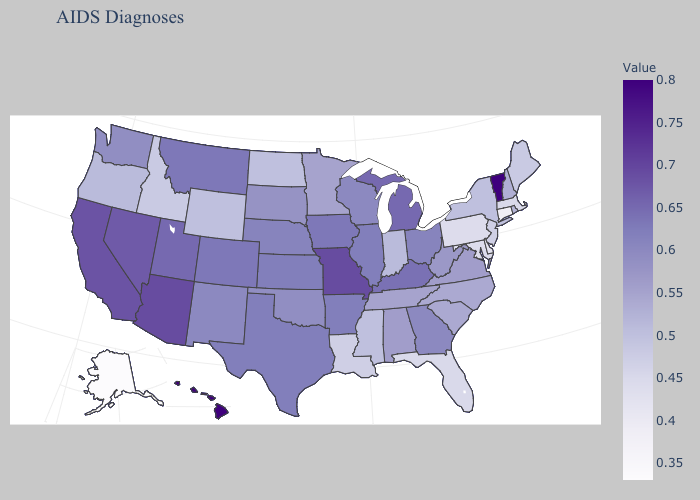Does the map have missing data?
Give a very brief answer. No. Does Hawaii have the highest value in the USA?
Be succinct. Yes. Which states have the lowest value in the MidWest?
Answer briefly. North Dakota. Is the legend a continuous bar?
Be succinct. Yes. Which states have the lowest value in the USA?
Short answer required. Alaska. Which states have the lowest value in the Northeast?
Concise answer only. Connecticut. Among the states that border Tennessee , does Arkansas have the lowest value?
Answer briefly. No. Among the states that border Oklahoma , does Missouri have the highest value?
Keep it brief. Yes. 